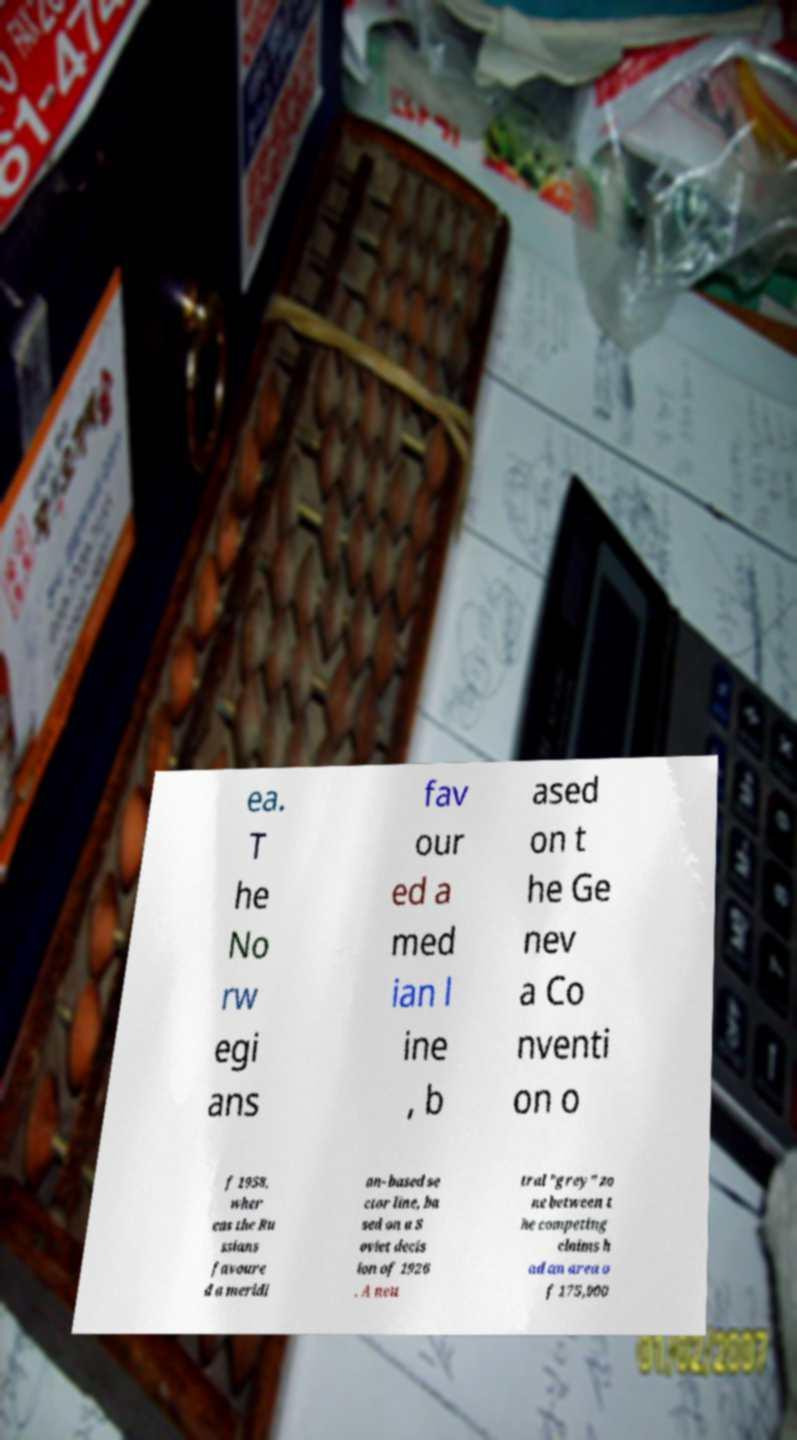For documentation purposes, I need the text within this image transcribed. Could you provide that? ea. T he No rw egi ans fav our ed a med ian l ine , b ased on t he Ge nev a Co nventi on o f 1958, wher eas the Ru ssians favoure d a meridi an- based se ctor line, ba sed on a S oviet decis ion of 1926 . A neu tral "grey" zo ne between t he competing claims h ad an area o f 175,000 